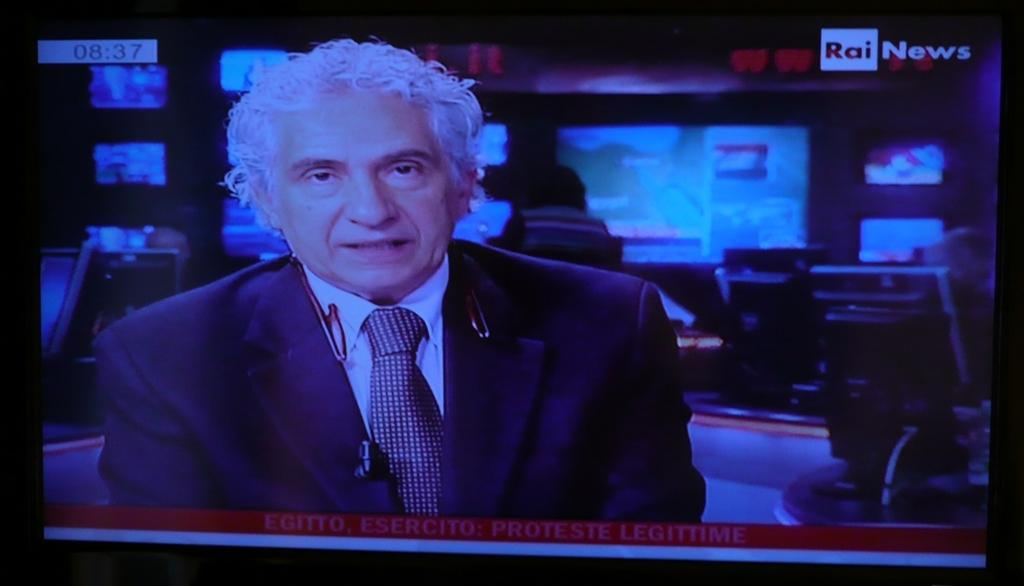What is displayed on the screen in the image? There is a picture of a person on the screen. Can you describe the person's attire in the picture? The person in the picture is wearing a coat and a tie. What else can be seen on the right side of the image? There are screens visible to the right side of the image. What is associated with the screens? There is text associated with the screens. What type of bait is being used to attract the person's brain in the image? There is no bait or brain present in the image; it features a picture of a person wearing a coat and a tie on a screen. 